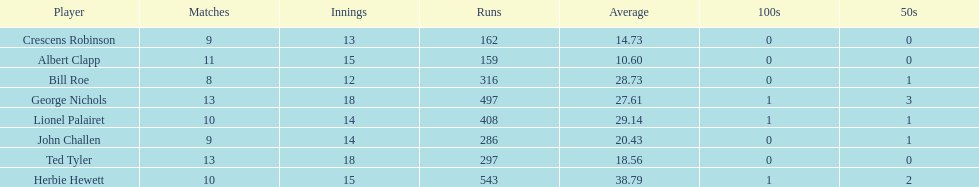Which player had the least amount of runs? Albert Clapp. 